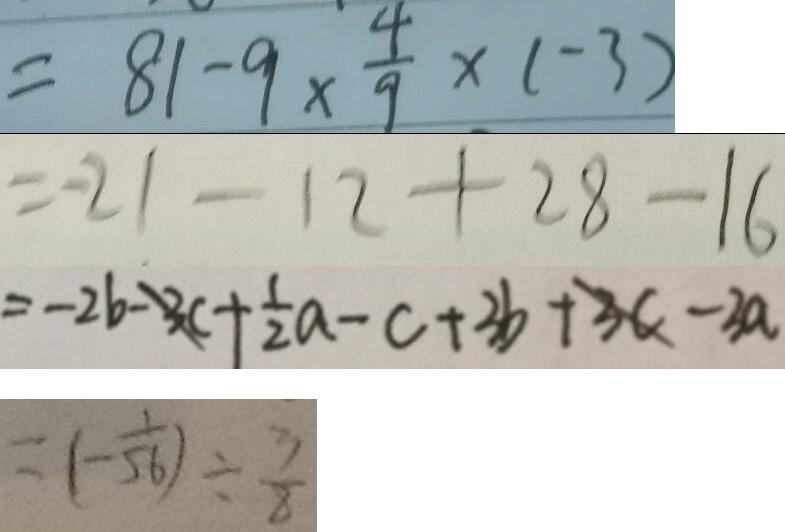<formula> <loc_0><loc_0><loc_500><loc_500>= 8 1 - 9 \times \frac { 4 } { 9 } \times ( - 3 ) 
 = - 2 1 - 1 2 + 2 8 - 1 6 
 = - 2 b - 3 c + \frac { 1 } { 2 } a - c + 3 b + 3 c - 3 a 
 = ( - \frac { 1 } { 5 6 } ) \div \frac { 3 } { 8 }</formula> 